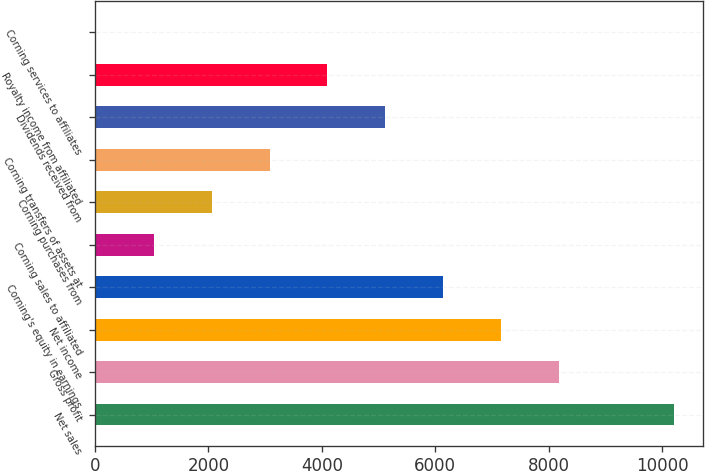Convert chart. <chart><loc_0><loc_0><loc_500><loc_500><bar_chart><fcel>Net sales<fcel>Gross profit<fcel>Net income<fcel>Corning's equity in earnings<fcel>Corning sales to affiliated<fcel>Corning purchases from<fcel>Corning transfers of assets at<fcel>Dividends received from<fcel>Royalty income from affiliated<fcel>Corning services to affiliates<nl><fcel>10211<fcel>8173.2<fcel>7154.3<fcel>6135.4<fcel>1040.9<fcel>2059.8<fcel>3078.7<fcel>5116.5<fcel>4097.6<fcel>22<nl></chart> 